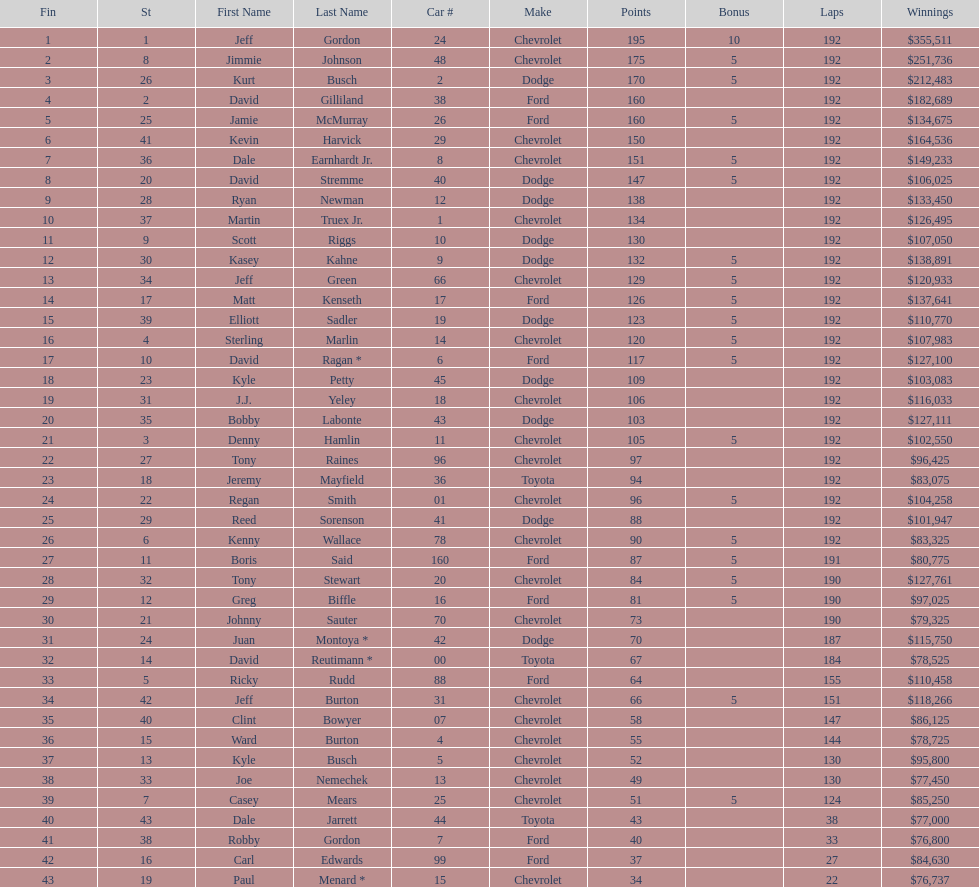How many drivers earned no bonus for this race? 23. 